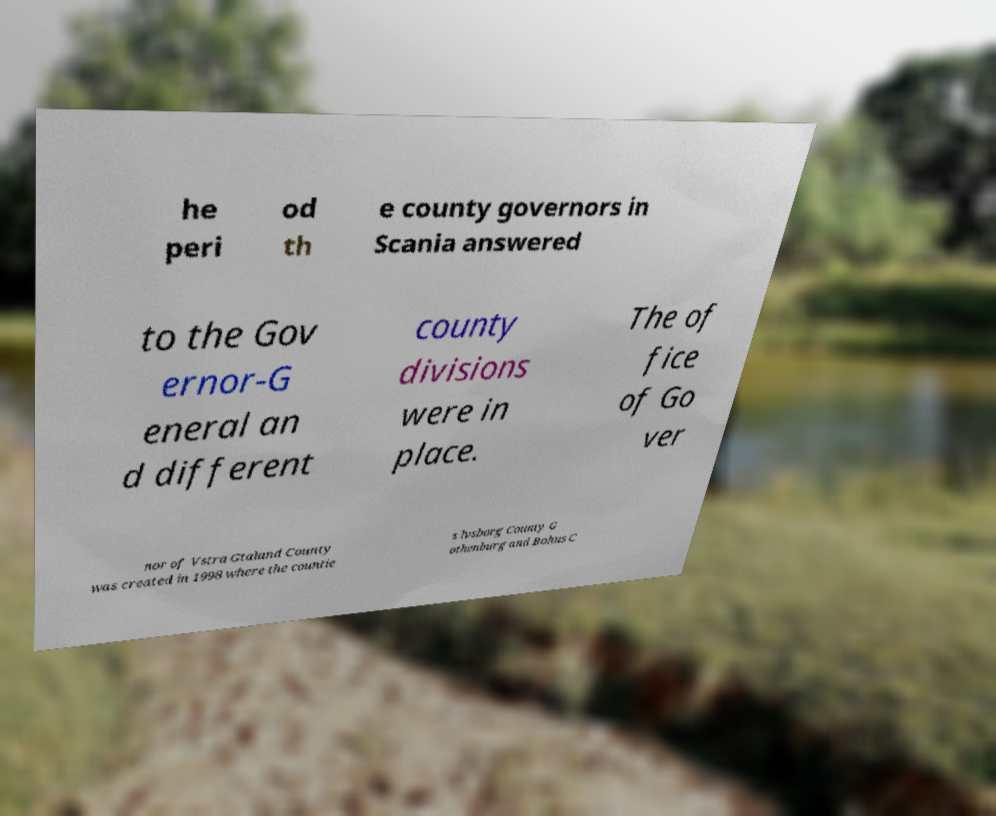Could you assist in decoding the text presented in this image and type it out clearly? he peri od th e county governors in Scania answered to the Gov ernor-G eneral an d different county divisions were in place. The of fice of Go ver nor of Vstra Gtaland County was created in 1998 where the countie s lvsborg County G othenburg and Bohus C 